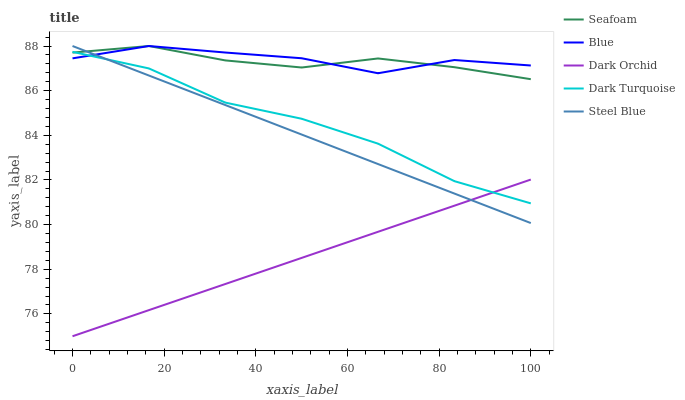Does Dark Orchid have the minimum area under the curve?
Answer yes or no. Yes. Does Dark Turquoise have the minimum area under the curve?
Answer yes or no. No. Does Dark Turquoise have the maximum area under the curve?
Answer yes or no. No. Is Dark Orchid the smoothest?
Answer yes or no. Yes. Is Blue the roughest?
Answer yes or no. Yes. Is Dark Turquoise the smoothest?
Answer yes or no. No. Is Dark Turquoise the roughest?
Answer yes or no. No. Does Dark Turquoise have the lowest value?
Answer yes or no. No. Does Dark Turquoise have the highest value?
Answer yes or no. No. Is Dark Orchid less than Blue?
Answer yes or no. Yes. Is Blue greater than Dark Orchid?
Answer yes or no. Yes. Does Dark Orchid intersect Blue?
Answer yes or no. No. 